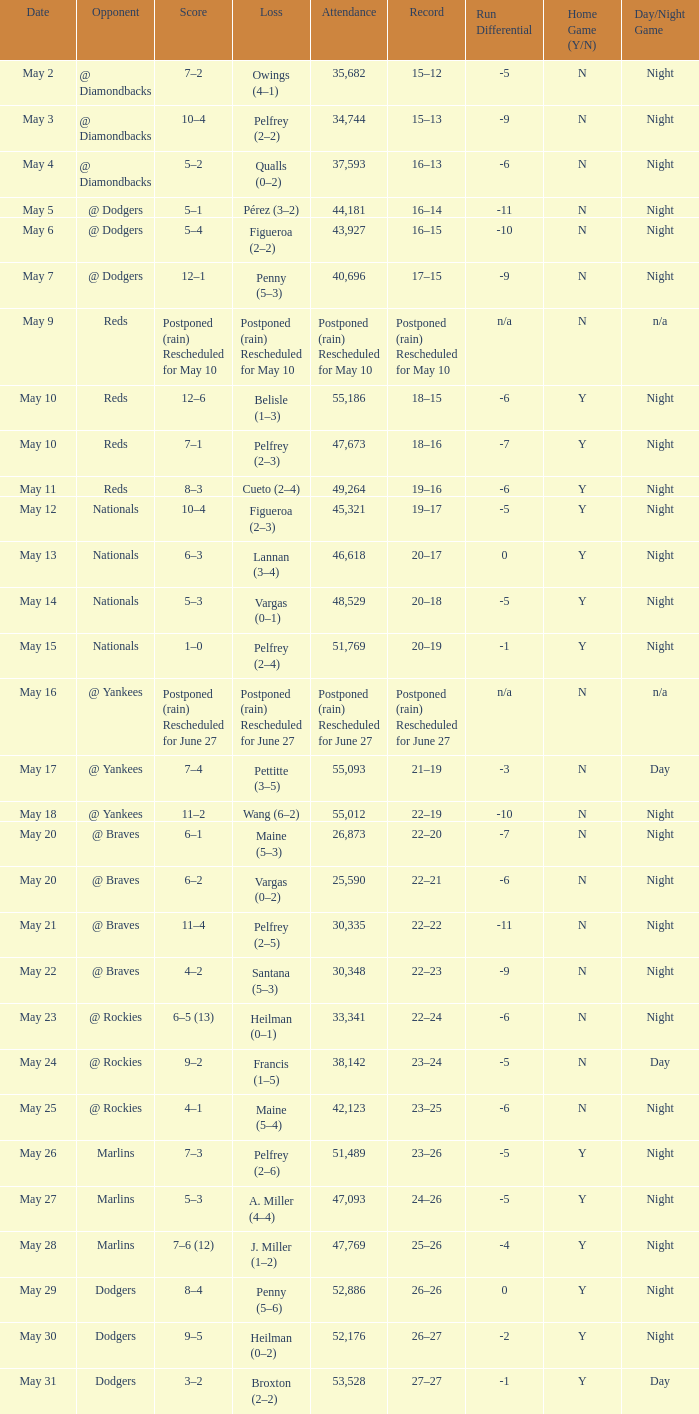Attendance of 30,335 had what record? 22–22. 